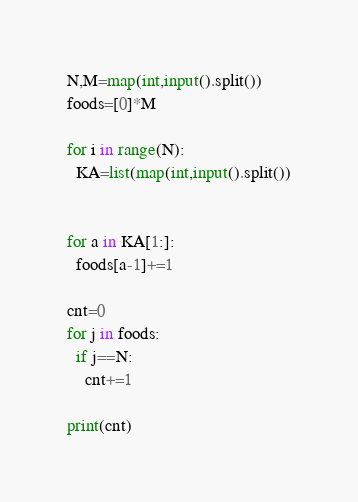<code> <loc_0><loc_0><loc_500><loc_500><_Python_>N,M=map(int,input().split())
foods=[0]*M

for i in range(N):
  KA=list(map(int,input().split())


for a in KA[1:]:
  foods[a-1]+=1

cnt=0
for j in foods:
  if j==N:
    cnt+=1

print(cnt)
</code> 